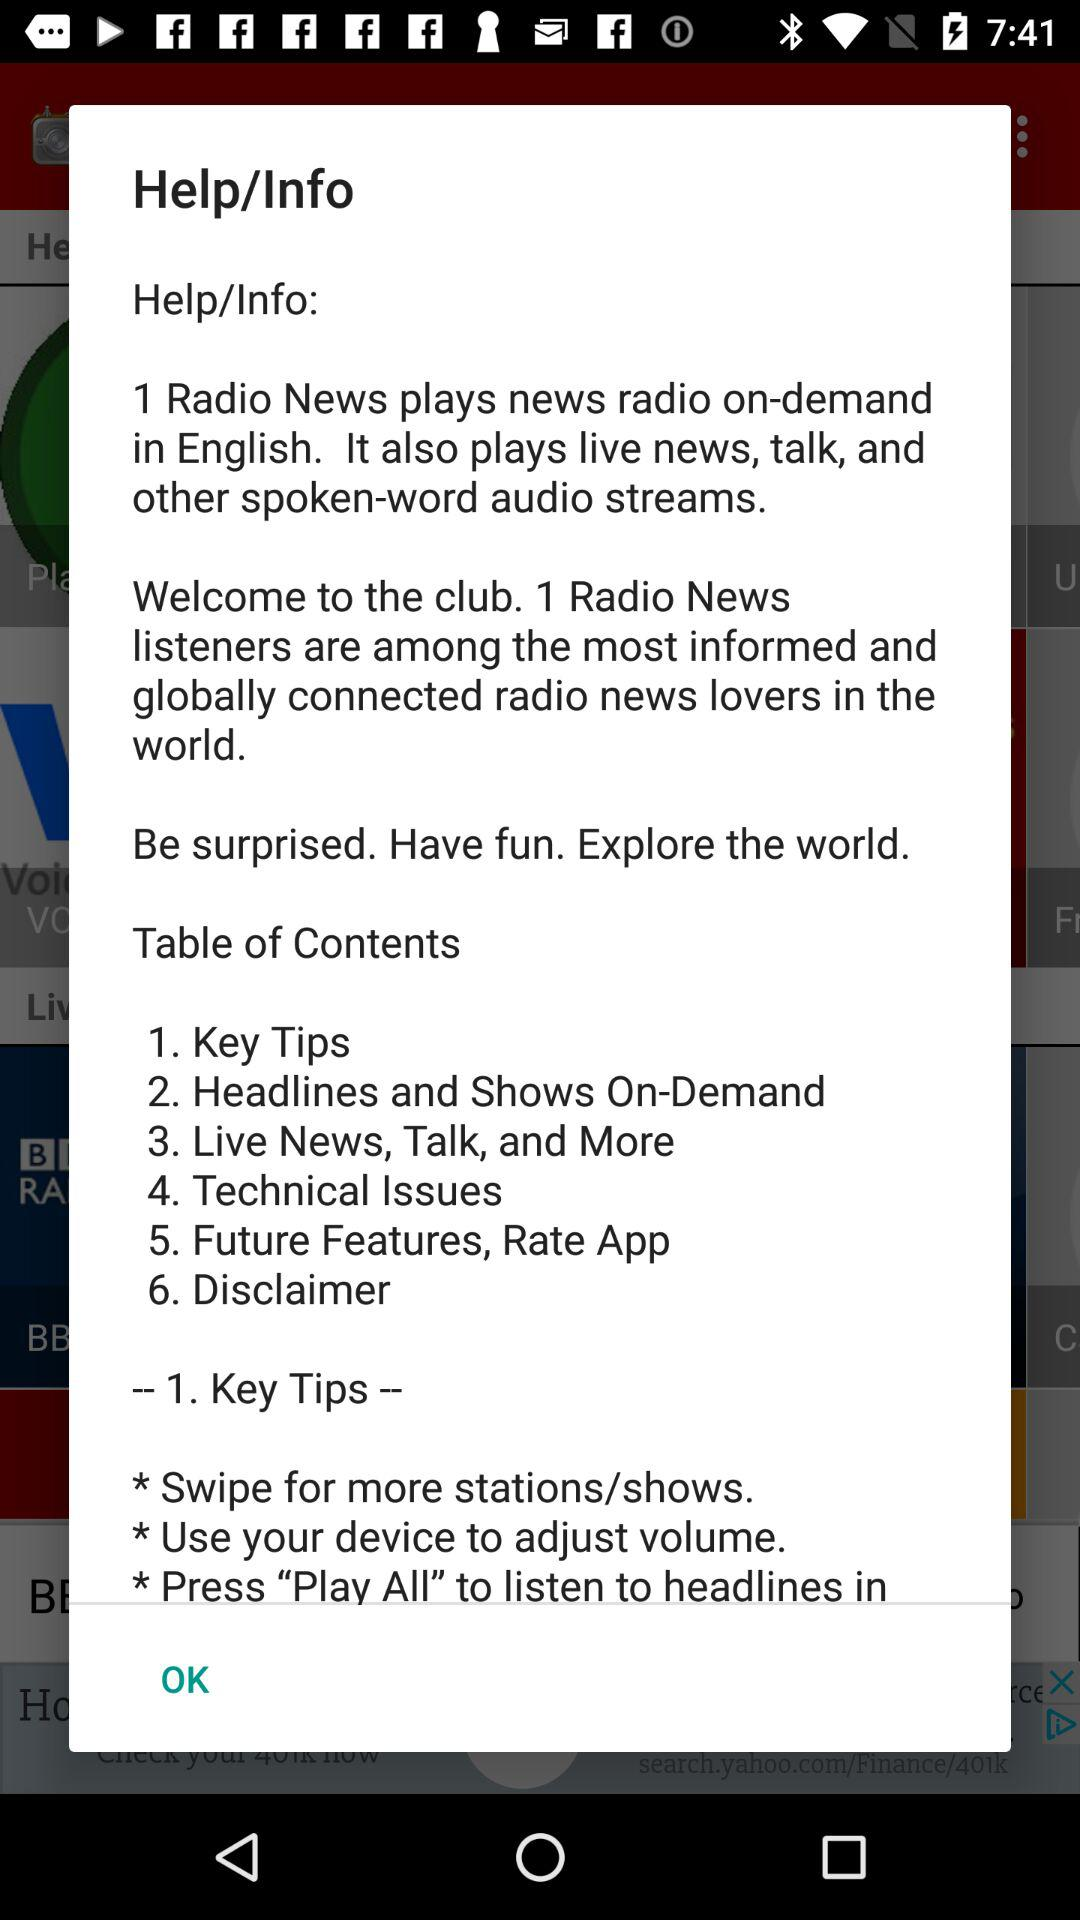How many key tips are there?
Answer the question using a single word or phrase. 3 